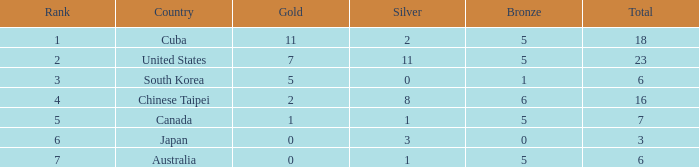What is the sum of the bronze medals when there were more than 2 silver medals and a rank larger than 6? None. 